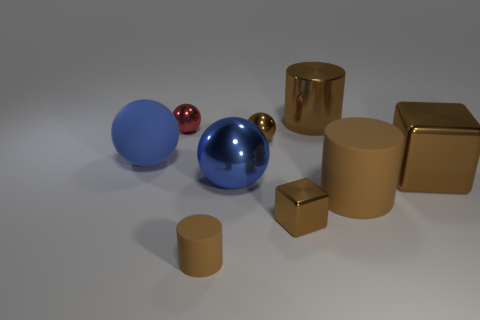How many brown cylinders must be subtracted to get 1 brown cylinders? 2 Subtract all big brown cylinders. How many cylinders are left? 1 Subtract 2 balls. How many balls are left? 2 Subtract all cyan spheres. Subtract all yellow blocks. How many spheres are left? 4 Add 1 large blue rubber balls. How many objects exist? 10 Subtract all cubes. How many objects are left? 7 Add 6 small brown metal spheres. How many small brown metal spheres exist? 7 Subtract 0 yellow cylinders. How many objects are left? 9 Subtract all large brown matte things. Subtract all tiny red things. How many objects are left? 7 Add 6 small red metal things. How many small red metal things are left? 7 